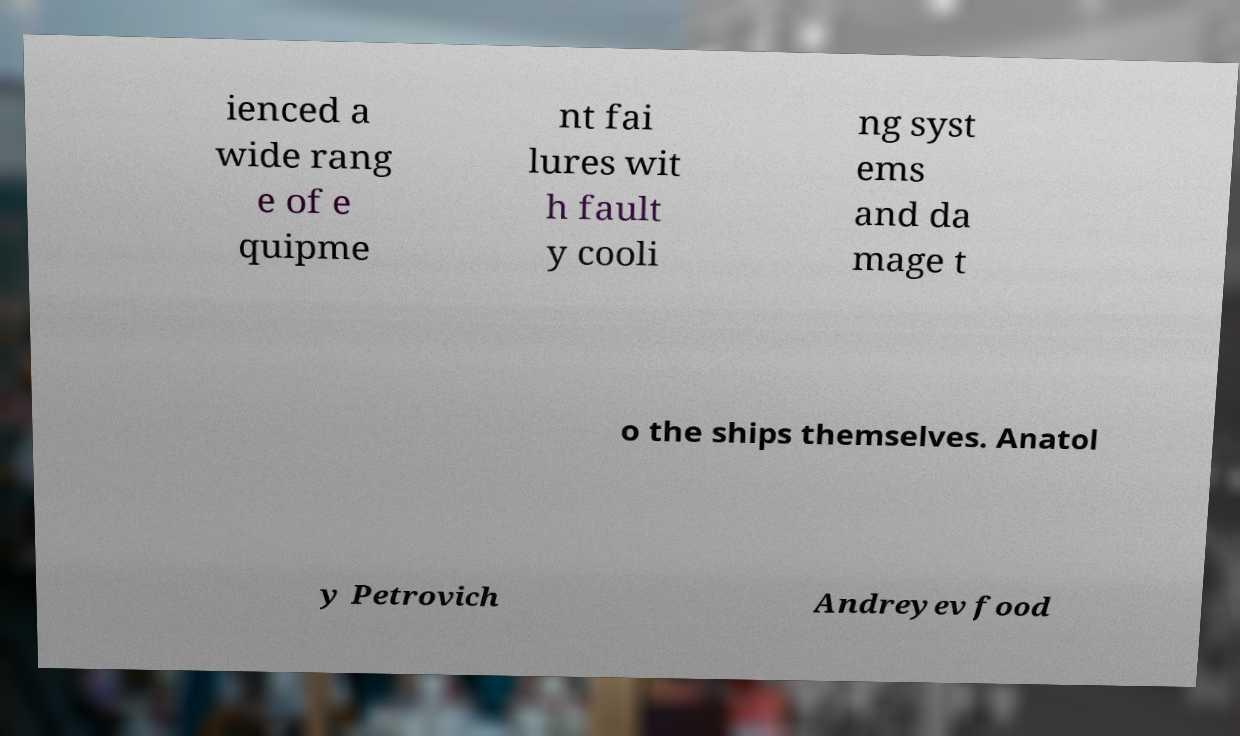Could you assist in decoding the text presented in this image and type it out clearly? ienced a wide rang e of e quipme nt fai lures wit h fault y cooli ng syst ems and da mage t o the ships themselves. Anatol y Petrovich Andreyev food 